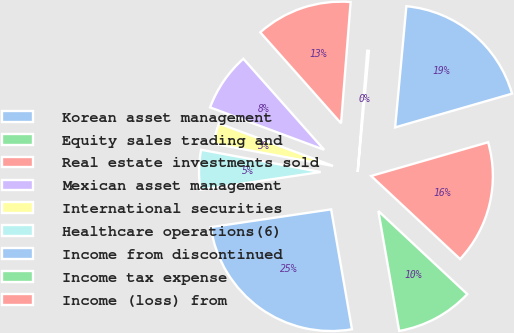<chart> <loc_0><loc_0><loc_500><loc_500><pie_chart><fcel>Korean asset management<fcel>Equity sales trading and<fcel>Real estate investments sold<fcel>Mexican asset management<fcel>International securities<fcel>Healthcare operations(6)<fcel>Income from discontinued<fcel>Income tax expense<fcel>Income (loss) from<nl><fcel>19.06%<fcel>0.22%<fcel>12.81%<fcel>7.78%<fcel>2.74%<fcel>5.26%<fcel>25.41%<fcel>10.3%<fcel>16.43%<nl></chart> 